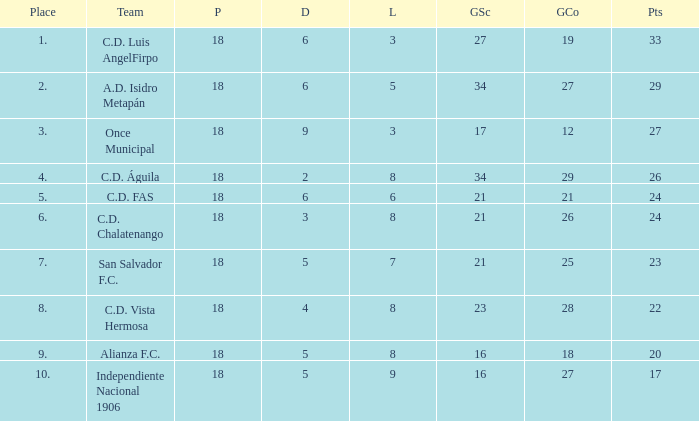How many points were in a game that had a lost of 5, greater than place 2, and 27 goals conceded? 0.0. 